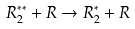<formula> <loc_0><loc_0><loc_500><loc_500>R _ { 2 } ^ { * * } + R \rightarrow R _ { 2 } ^ { * } + R</formula> 